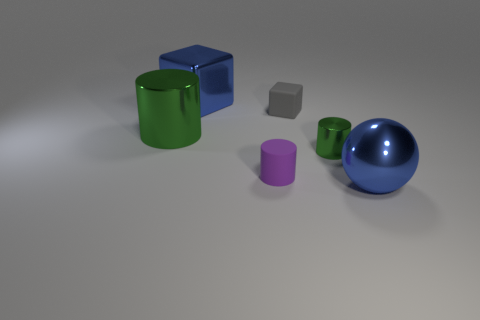There is a object that is the same color as the large ball; what size is it?
Ensure brevity in your answer.  Large. How many small purple cylinders are made of the same material as the small gray block?
Your answer should be compact. 1. How many blue things are right of the big blue metal thing that is behind the blue sphere?
Give a very brief answer. 1. There is a tiny thing that is behind the big green thing; does it have the same color as the small rubber object in front of the large green shiny cylinder?
Provide a succinct answer. No. There is a object that is in front of the small metallic cylinder and to the left of the metal sphere; what shape is it?
Offer a very short reply. Cylinder. Is there a tiny gray matte object that has the same shape as the tiny metallic object?
Provide a short and direct response. No. What shape is the green metal thing that is the same size as the blue cube?
Your answer should be compact. Cylinder. What is the ball made of?
Your answer should be compact. Metal. What is the size of the metallic cylinder in front of the big green shiny object behind the shiny object that is to the right of the tiny green shiny cylinder?
Offer a terse response. Small. What is the material of the object that is the same color as the metal block?
Provide a short and direct response. Metal. 